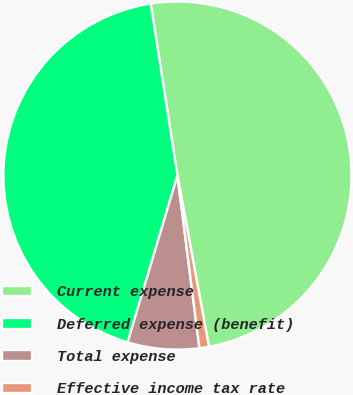Convert chart. <chart><loc_0><loc_0><loc_500><loc_500><pie_chart><fcel>Current expense<fcel>Deferred expense (benefit)<fcel>Total expense<fcel>Effective income tax rate<nl><fcel>49.56%<fcel>42.92%<fcel>6.64%<fcel>0.88%<nl></chart> 